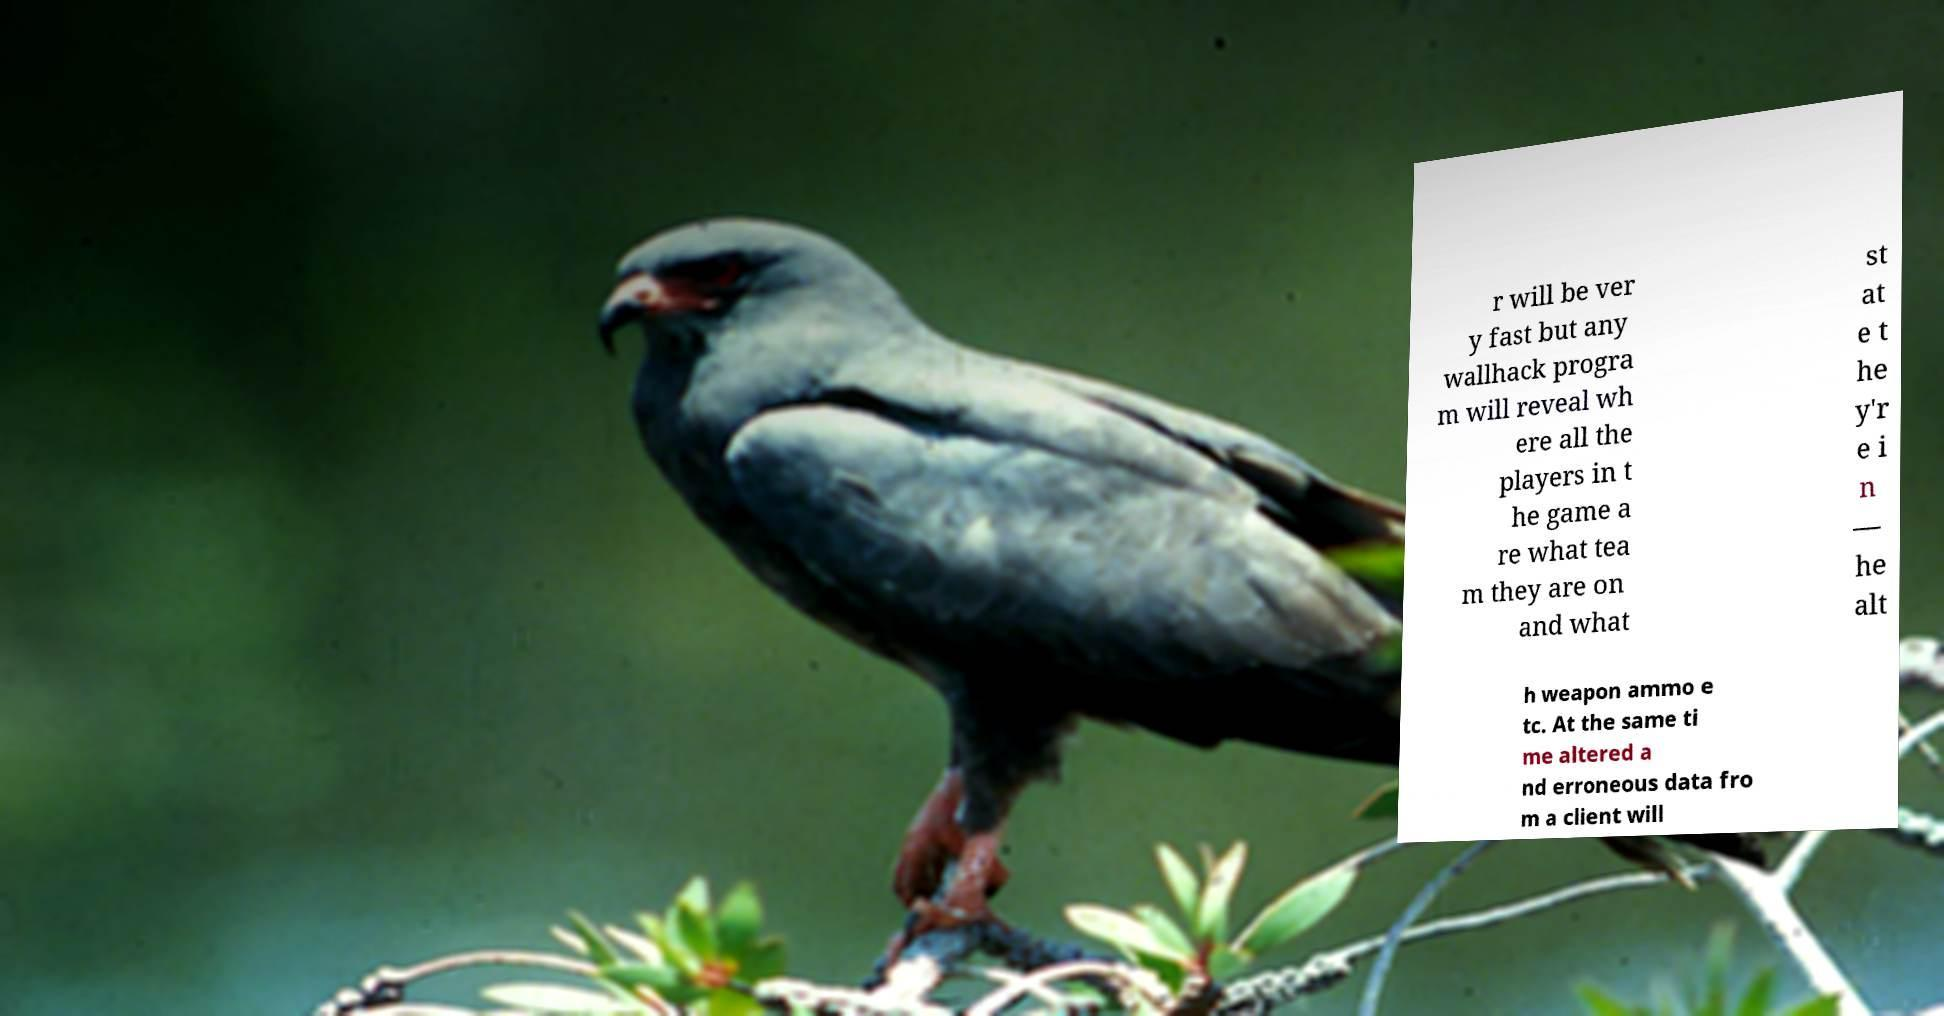For documentation purposes, I need the text within this image transcribed. Could you provide that? r will be ver y fast but any wallhack progra m will reveal wh ere all the players in t he game a re what tea m they are on and what st at e t he y'r e i n — he alt h weapon ammo e tc. At the same ti me altered a nd erroneous data fro m a client will 